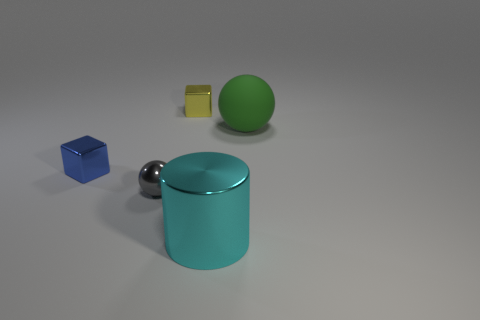Add 2 big shiny cylinders. How many objects exist? 7 Subtract all balls. How many objects are left? 3 Add 1 small cyan blocks. How many small cyan blocks exist? 1 Subtract 0 green blocks. How many objects are left? 5 Subtract all cyan things. Subtract all large rubber things. How many objects are left? 3 Add 5 yellow metallic objects. How many yellow metallic objects are left? 6 